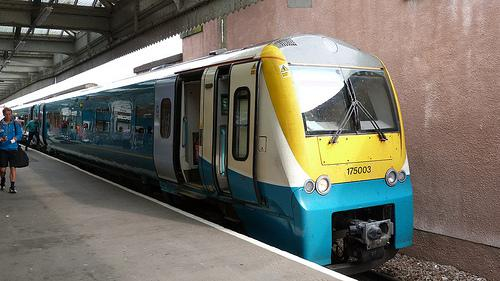Question: where was this picture taken?
Choices:
A. The airport.
B. The pool.
C. The mall.
D. A train platform.
Answer with the letter. Answer: D Question: what color is the train?
Choices:
A. Yellow and blue.
B. Black and brown.
C. Green and red.
D. Orange and white.
Answer with the letter. Answer: A Question: what color are the walls?
Choices:
A. White.
B. Tan.
C. Grey.
D. Brown.
Answer with the letter. Answer: B Question: who is in the picture?
Choices:
A. My sister.
B. A man.
C. The neighbor.
D. Your friend.
Answer with the letter. Answer: B Question: what kind of train is this?
Choices:
A. Electric.
B. A subway.
C. Cargo.
D. Passenger.
Answer with the letter. Answer: B 